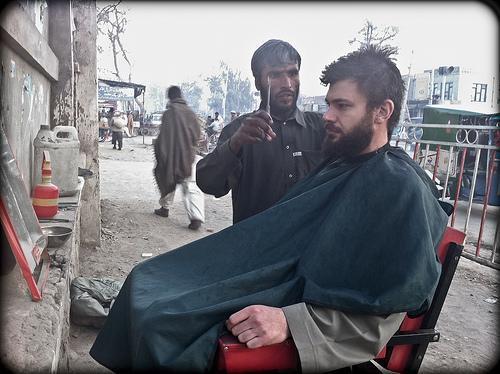How many people are holding scissors?
Give a very brief answer. 1. 